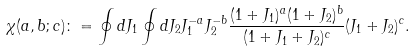Convert formula to latex. <formula><loc_0><loc_0><loc_500><loc_500>\chi ( a , b ; c ) \colon = \oint d J _ { 1 } \oint d J _ { 2 } J _ { 1 } ^ { - a } J _ { 2 } ^ { - b } \frac { ( 1 + J _ { 1 } ) ^ { a } ( 1 + J _ { 2 } ) ^ { b } } { ( 1 + J _ { 1 } + J _ { 2 } ) ^ { c } } ( J _ { 1 } + J _ { 2 } ) ^ { c } .</formula> 